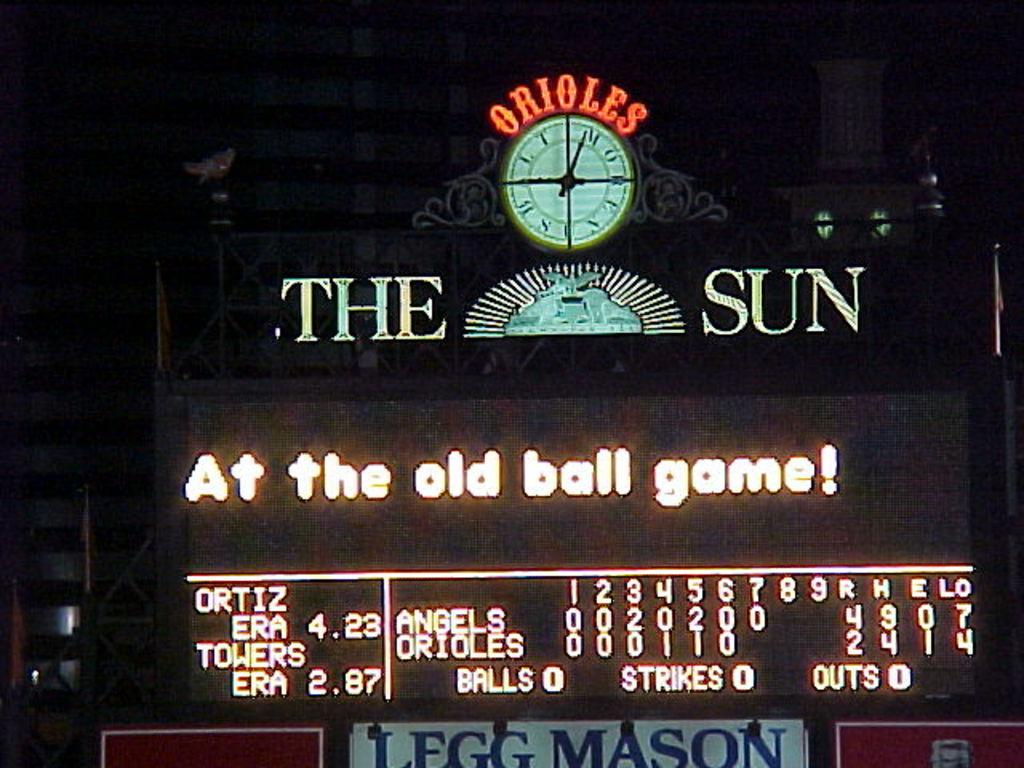<image>
Offer a succinct explanation of the picture presented. Scoreboard at a sports game that says "At the old ball game!". 